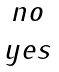<formula> <loc_0><loc_0><loc_500><loc_500>\begin{array} { c } n o \\ y e s \end{array}</formula> 